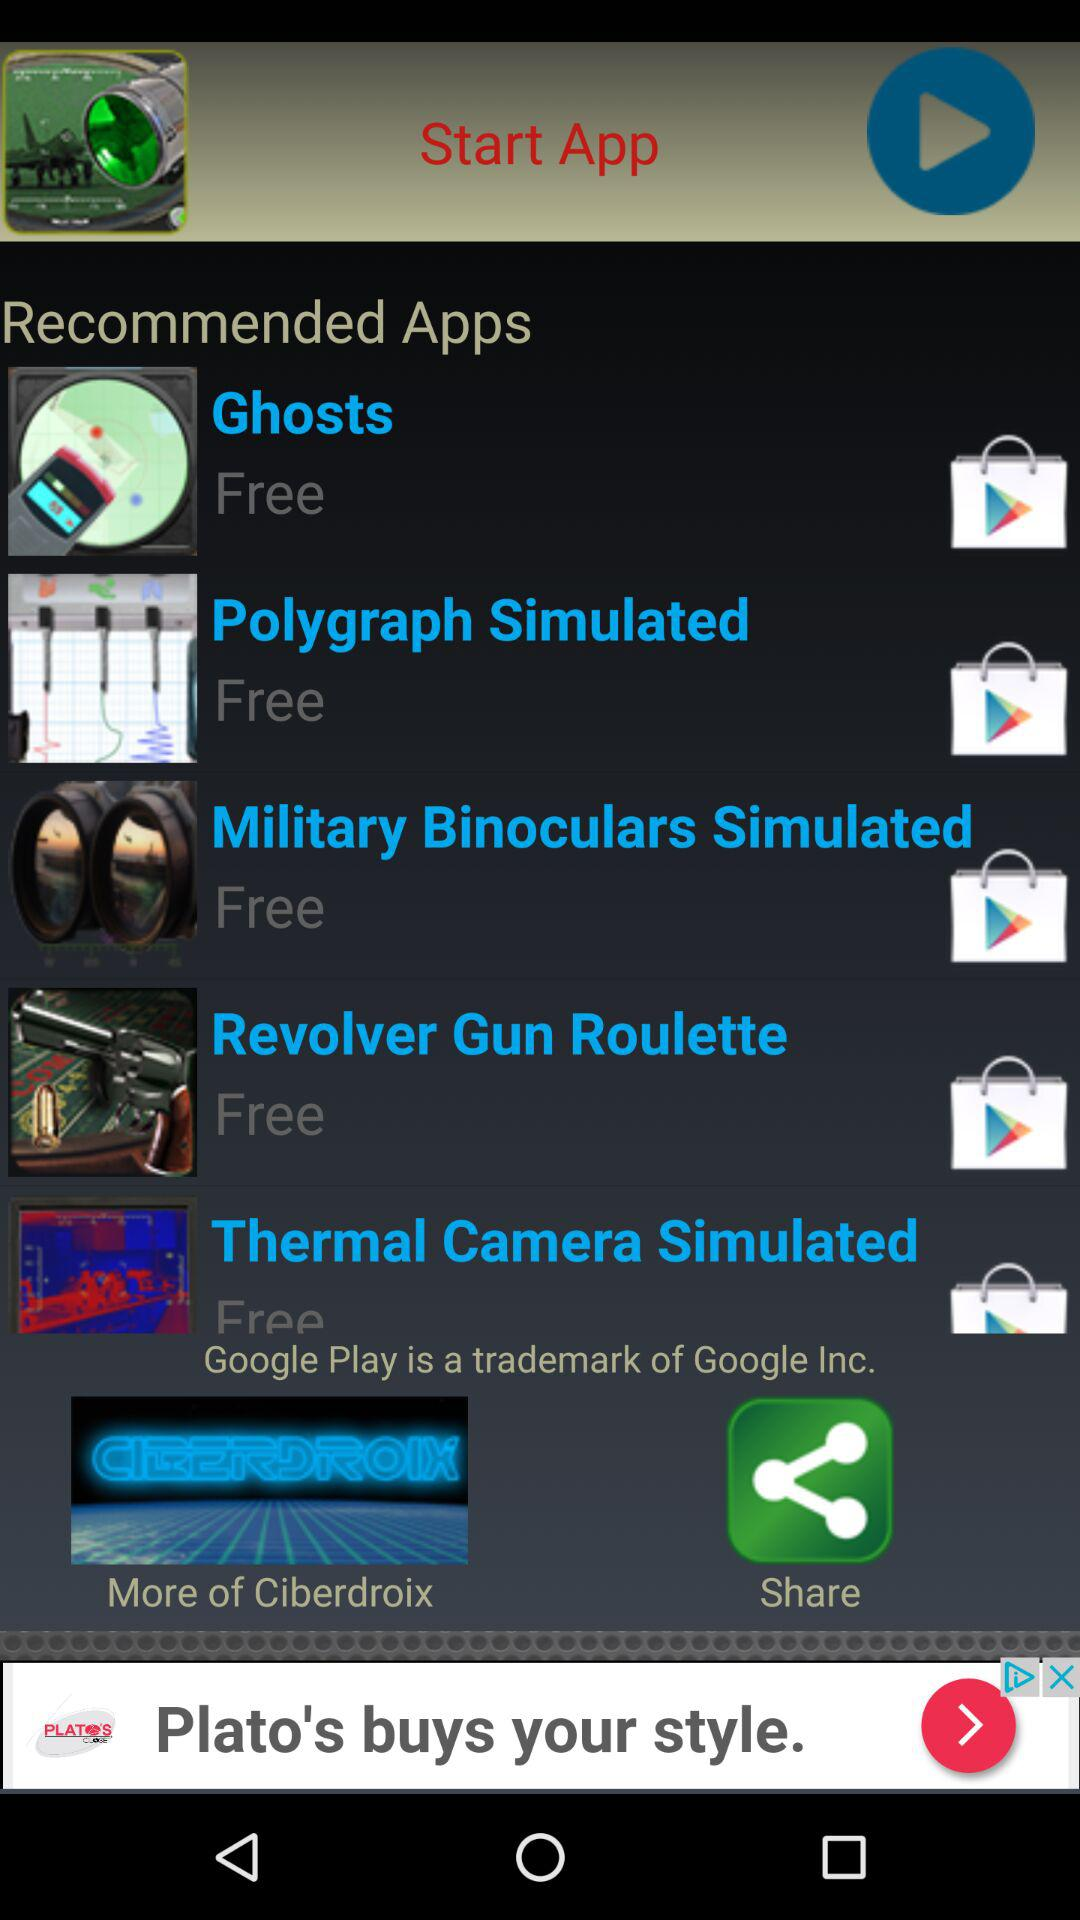What is the price of "Military Binoculars Simulated"? "Military Binoculars Simulated" is free. 